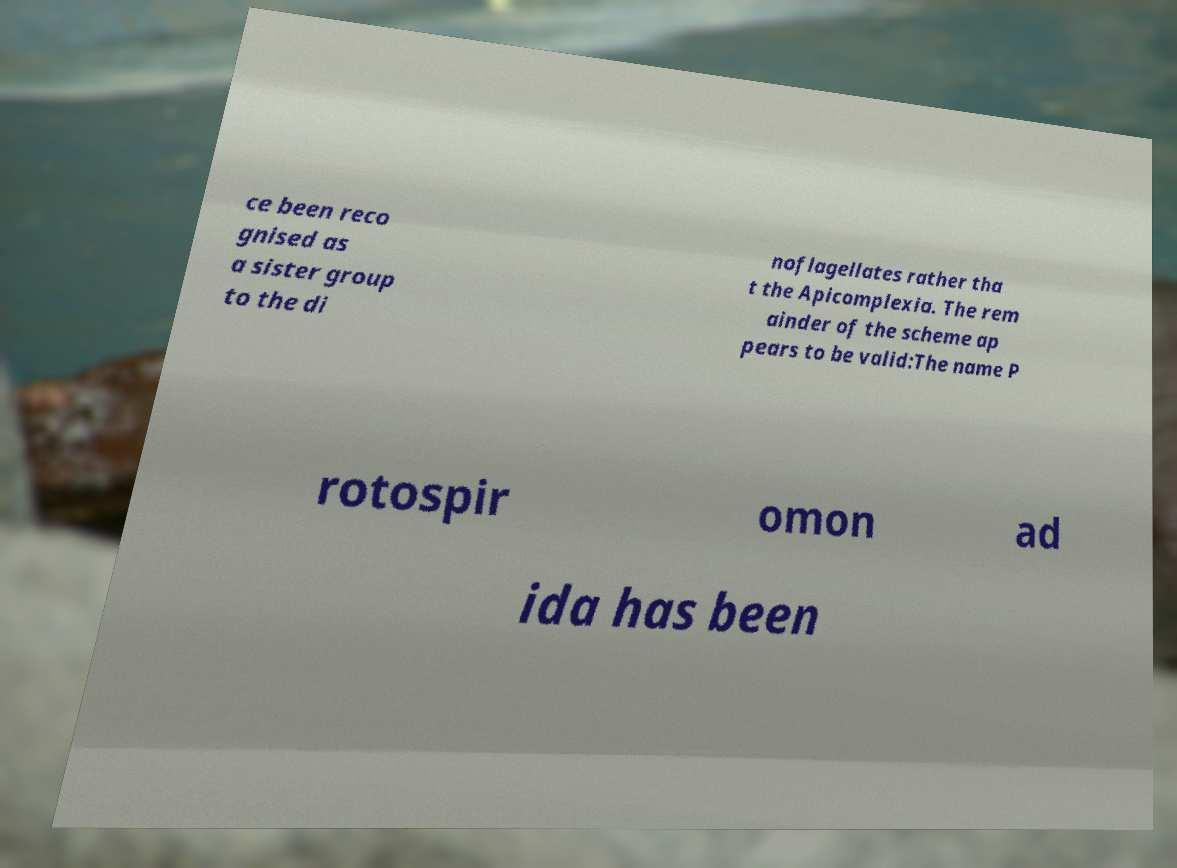For documentation purposes, I need the text within this image transcribed. Could you provide that? ce been reco gnised as a sister group to the di noflagellates rather tha t the Apicomplexia. The rem ainder of the scheme ap pears to be valid:The name P rotospir omon ad ida has been 